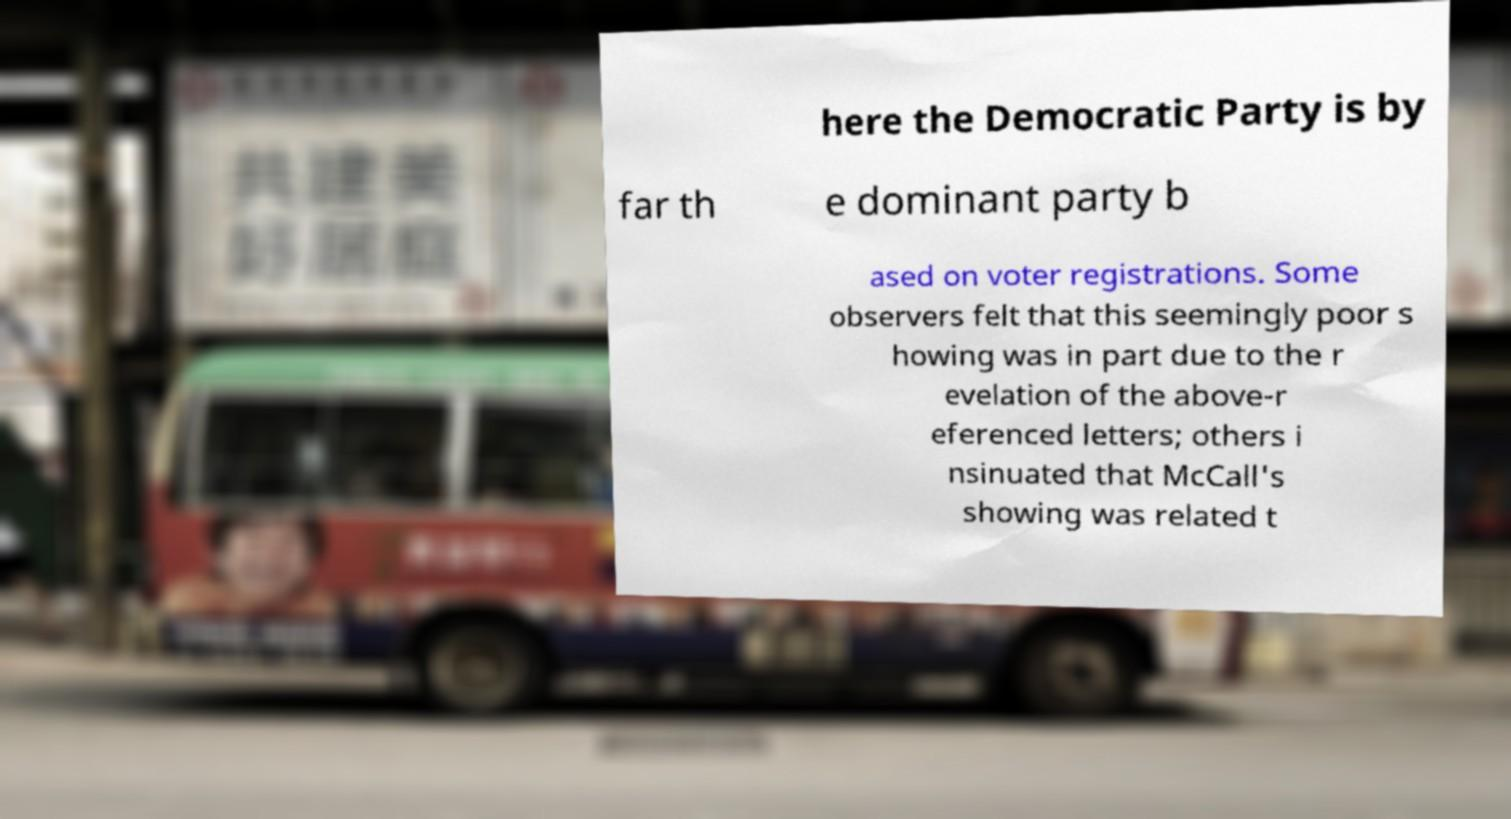There's text embedded in this image that I need extracted. Can you transcribe it verbatim? here the Democratic Party is by far th e dominant party b ased on voter registrations. Some observers felt that this seemingly poor s howing was in part due to the r evelation of the above-r eferenced letters; others i nsinuated that McCall's showing was related t 